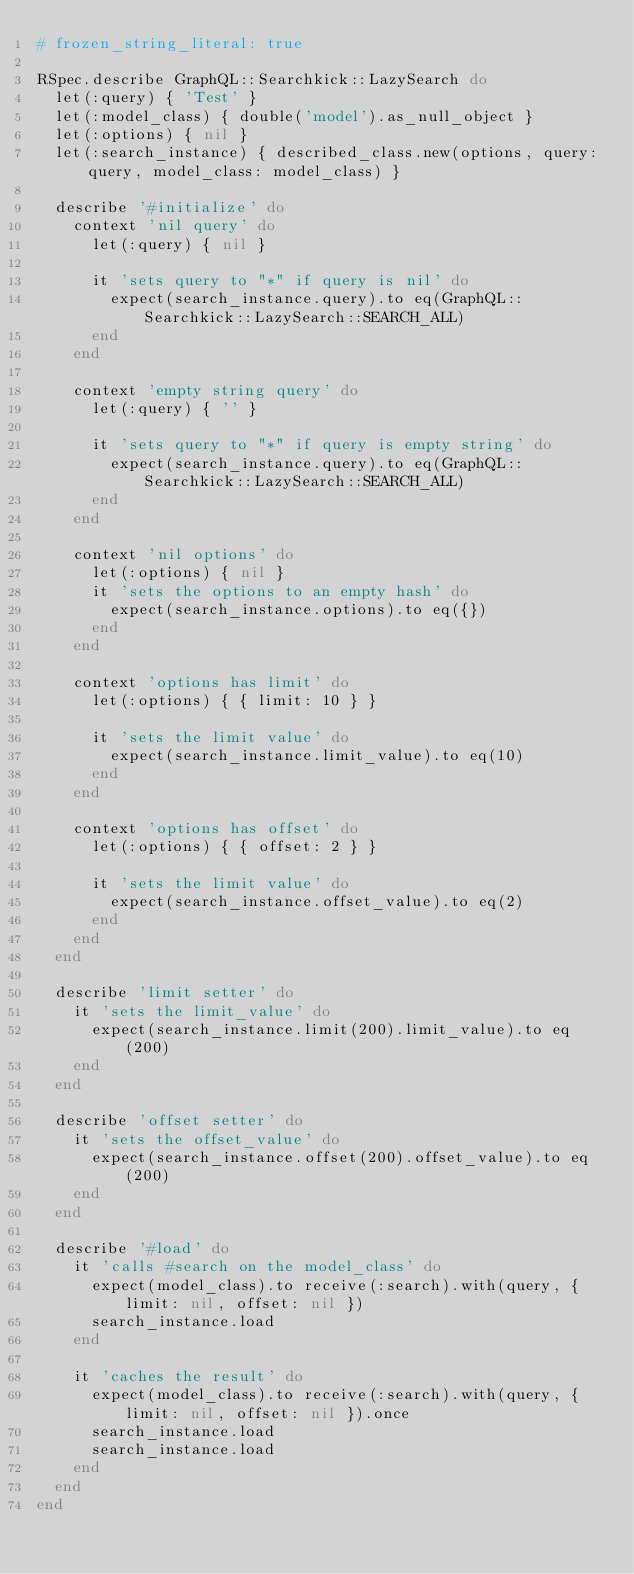Convert code to text. <code><loc_0><loc_0><loc_500><loc_500><_Ruby_># frozen_string_literal: true

RSpec.describe GraphQL::Searchkick::LazySearch do
  let(:query) { 'Test' }
  let(:model_class) { double('model').as_null_object }
  let(:options) { nil }
  let(:search_instance) { described_class.new(options, query: query, model_class: model_class) }

  describe '#initialize' do
    context 'nil query' do
      let(:query) { nil }

      it 'sets query to "*" if query is nil' do
        expect(search_instance.query).to eq(GraphQL::Searchkick::LazySearch::SEARCH_ALL)
      end
    end

    context 'empty string query' do
      let(:query) { '' }

      it 'sets query to "*" if query is empty string' do
        expect(search_instance.query).to eq(GraphQL::Searchkick::LazySearch::SEARCH_ALL)
      end
    end

    context 'nil options' do
      let(:options) { nil }
      it 'sets the options to an empty hash' do
        expect(search_instance.options).to eq({})
      end
    end

    context 'options has limit' do
      let(:options) { { limit: 10 } }

      it 'sets the limit value' do
        expect(search_instance.limit_value).to eq(10)
      end
    end

    context 'options has offset' do
      let(:options) { { offset: 2 } }

      it 'sets the limit value' do
        expect(search_instance.offset_value).to eq(2)
      end
    end
  end

  describe 'limit setter' do
    it 'sets the limit_value' do
      expect(search_instance.limit(200).limit_value).to eq(200)
    end
  end

  describe 'offset setter' do
    it 'sets the offset_value' do
      expect(search_instance.offset(200).offset_value).to eq(200)
    end
  end

  describe '#load' do
    it 'calls #search on the model_class' do
      expect(model_class).to receive(:search).with(query, { limit: nil, offset: nil })
      search_instance.load
    end

    it 'caches the result' do
      expect(model_class).to receive(:search).with(query, { limit: nil, offset: nil }).once
      search_instance.load
      search_instance.load
    end
  end
end
</code> 